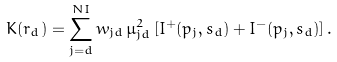<formula> <loc_0><loc_0><loc_500><loc_500>K ( r _ { d } ) = \sum _ { j = d } ^ { N I } w _ { j d } \, \mu _ { j d } ^ { 2 } \, [ I ^ { + } ( p _ { j } , s _ { d } ) + I ^ { - } ( p _ { j } , s _ { d } ) ] \, .</formula> 